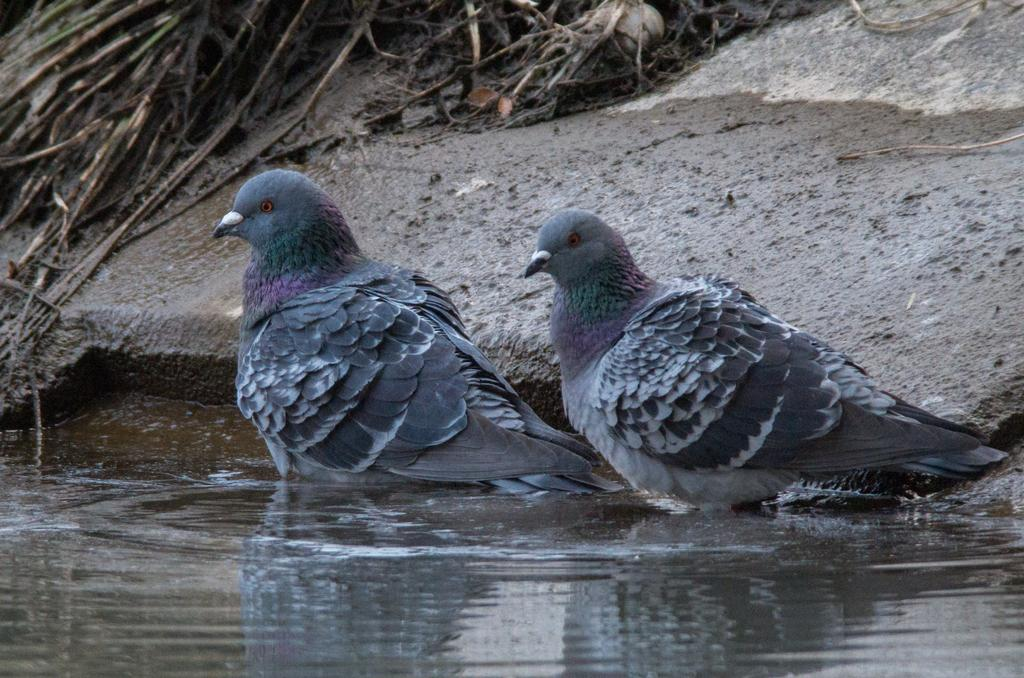What is the main subject in the center of the picture? There are pigeons in the center of the picture. What can be seen in the foreground of the image? There is water in the foreground of the image. What is visible in the background of the image? There are waste materials and soil in the background of the image. What type of oil can be seen dripping from the pigeons in the image? There is no oil present in the image; it features pigeons, water, waste materials, and soil. Is there a spy observing the pigeons in the image? There is no indication of a spy or any person in the image; it only shows pigeons, water, waste materials, and soil. 